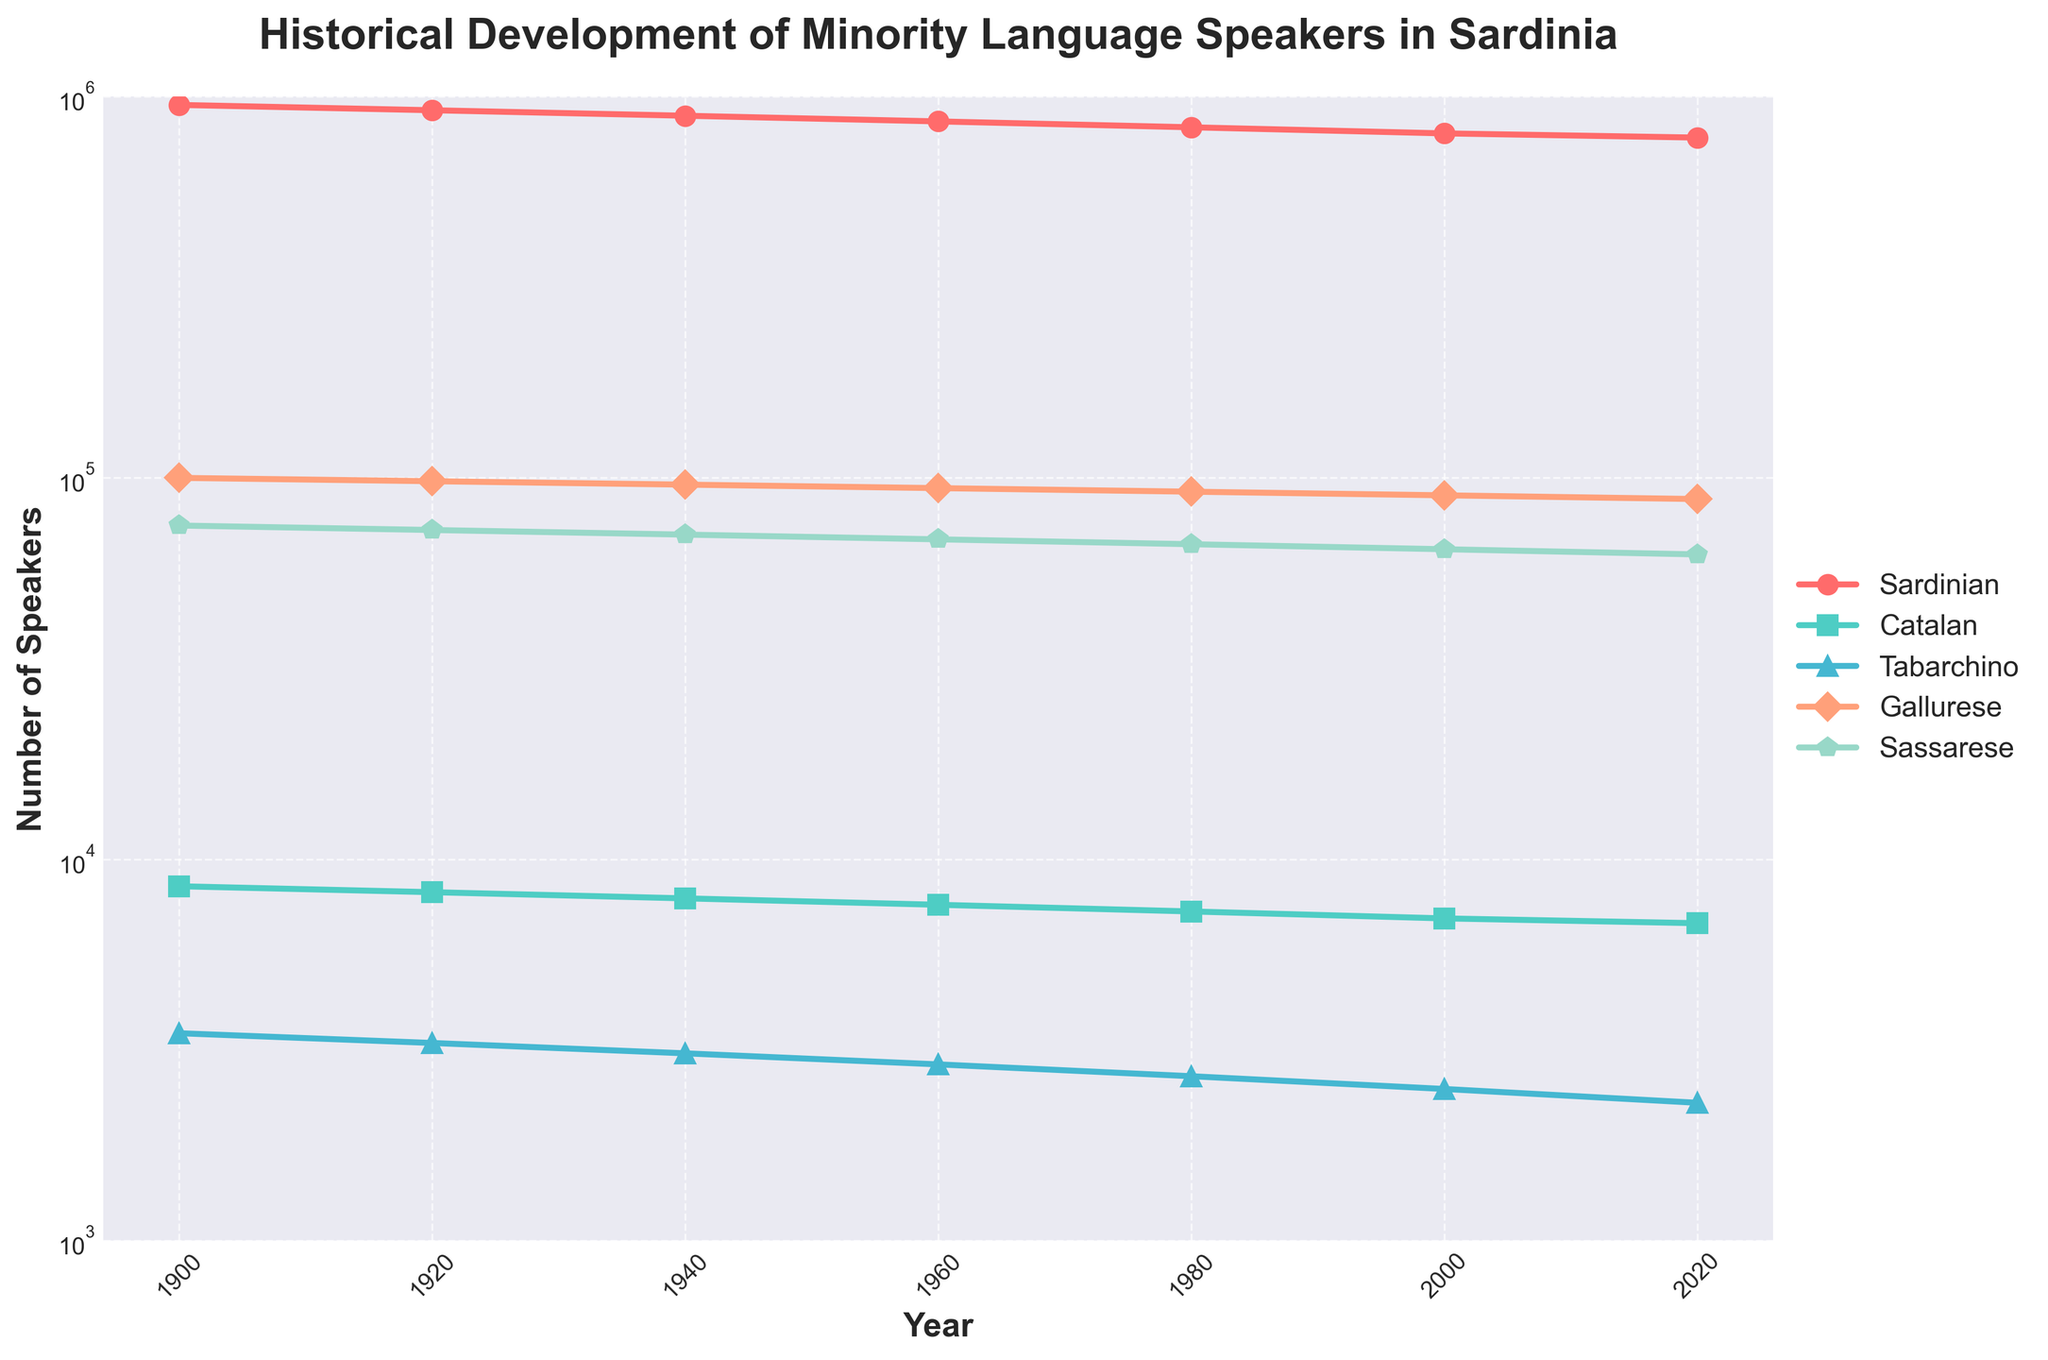What's the predominant minority language spoken in Sardinia in 1900? To determine the predominant language, you need to compare the speaker numbers for each language in 1900: Sardinian (950,000), Catalan (8,500), Tabarchino (3,500), Gallurese (100,000), and Sassarese (75,000). Sardinian has the highest number of speakers.
Answer: Sardinian What is the total number of minority language speakers in Sardinia in 2020? Sum up the number of speakers of each language in 2020: Sardinian (780,000), Catalan (6,800), Tabarchino (2,300), Gallurese (88,000), and Sassarese (63,000). Total = 780,000 + 6,800 + 2,300 + 88,000 + 63,000 = 940,100.
Answer: 940,100 Which minority language saw the least decline in speakers from 1900 to 2020? Calculate the decline for each language by subtracting the number of speakers in 2020 from the number in 1900: Sardinian (950,000 - 780,000 = 170,000), Catalan (8,500 - 6,800 = 1,700), Tabarchino (3,500 - 2,300 = 1,200), Gallurese (100,000 - 88,000 = 12,000), and Sassarese (75,000 - 63,000 = 12,000). The smallest decline is for Tabarchino with a decline of 1,200.
Answer: Tabarchino In what year did the number of Sardinian speakers fall below 900,000? By looking at the trend of Sardinian speakers, the number drops below 900,000 between 1920 (920,000) and 1940 (890,000). Hence, the year is 1940.
Answer: 1940 Which language maintained the most stable number of speakers from 1900 to 2020? By observing the lines on the chart, you can see that Gallurese shows the smallest variation, starting from 100,000 in 1900 and ending at 88,000 in 2020, indicating greater stability compared to the other languages.
Answer: Gallurese If you sum up the speakers of Catalan and Tabarchino in 1960, how many speakers do you get? Catalan had 7,600 speakers and Tabarchino had 2,900 speakers in 1960. Sum = 7,600 + 2,900 = 10,500.
Answer: 10,500 Which two languages' speaker counts are closest to each other in 2000? In 2000, the number of speakers are Sardinian (800,000), Catalan (7,000), Tabarchino (2,500), Gallurese (90,000), and Sassarese (65,000). Catalan (7,000) and Tabarchino (2,500) have the smallest difference: 7,000 - 2,500 = 4,500.
Answer: Catalan and Tabarchino How does the trend of Catalan speakers from 1900 to 2020 visually compare to that of Tabarchino speakers? Both Catalan and Tabarchino show a gradual decline over the years, but Catalan starts with a higher number of speakers and maintains a steeper decline compared to the more stable but smaller numbers of Tabarchino.
Answer: Steeper decline for Catalan If you take the average number of Gallurese speakers every 20 years, what is the average value? The numbers every 20 years for Gallurese are 100,000 (1900), 98,000 (1920), 96,000 (1940), 94,000 (1960), 92,000 (1980), 90,000 (2000), and 88,000 (2020). Average = (100,000 + 98,000 + 96,000 + 94,000 + 92,000 + 90,000 + 88,000) / 7 ≈ 94,000.
Answer: 94,000 Which language shows the second highest number of speakers in 1920? In 1920, the number of speakers are Sardinian (920,000), Catalan (8,200), Tabarchino (3,300), Gallurese (98,000), and Sassarese (73,000). Gallurese is the second highest with 98,000 speakers.
Answer: Gallurese 